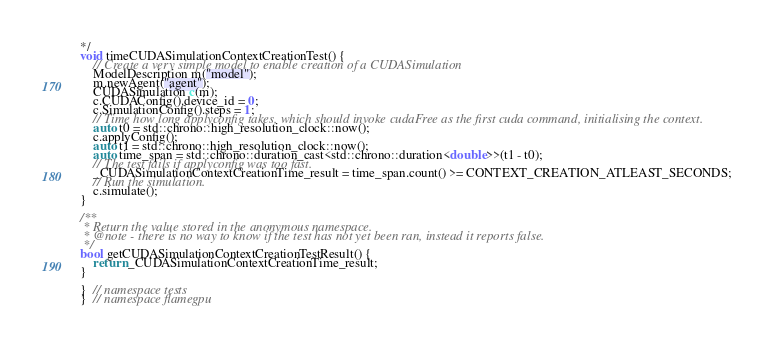Convert code to text. <code><loc_0><loc_0><loc_500><loc_500><_Cuda_>*/
void timeCUDASimulationContextCreationTest() {
    // Create a very simple model to enable creation of a CUDASimulation
    ModelDescription m("model");
    m.newAgent("agent");
    CUDASimulation c(m);
    c.CUDAConfig().device_id = 0;
    c.SimulationConfig().steps = 1;
    // Time how long applyconfig takes, which should invoke cudaFree as the first cuda command, initialising the context.
    auto t0 = std::chrono::high_resolution_clock::now();
    c.applyConfig();
    auto t1 = std::chrono::high_resolution_clock::now();
    auto time_span = std::chrono::duration_cast<std::chrono::duration<double>>(t1 - t0);
    // The test fails if applyconfig was too fast.
    _CUDASimulationContextCreationTime_result = time_span.count() >= CONTEXT_CREATION_ATLEAST_SECONDS;
    // Run the simulation.
    c.simulate();
}

/**
 * Return the value stored in the anonymous namespace.
 * @note - there is no way to know if the test has not yet been ran, instead it reports false.
 */
bool getCUDASimulationContextCreationTestResult() {
    return _CUDASimulationContextCreationTime_result;
}

}  // namespace tests
}  // namespace flamegpu
</code> 